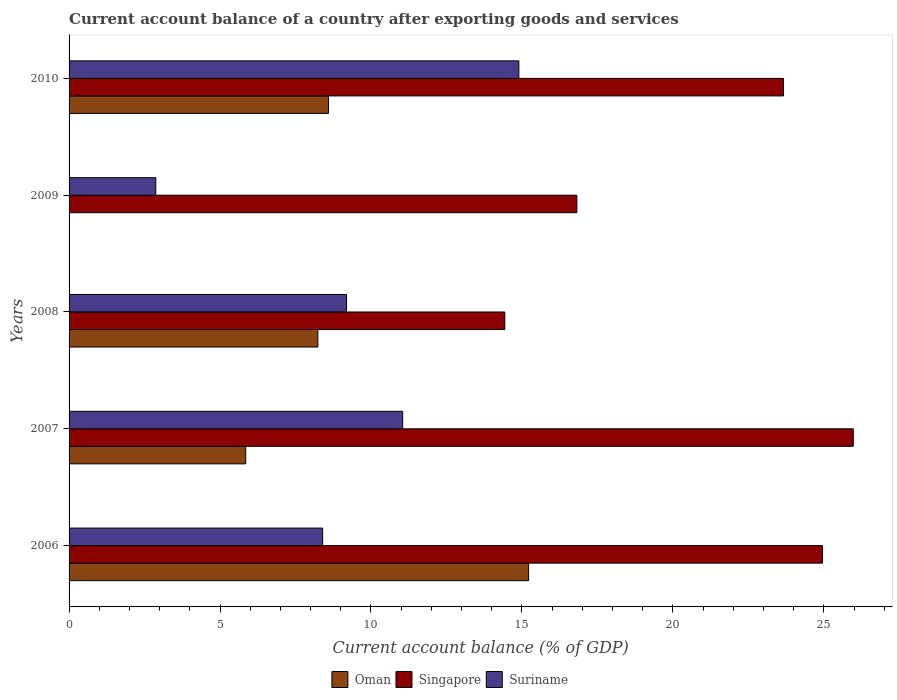How many different coloured bars are there?
Provide a succinct answer. 3. Are the number of bars per tick equal to the number of legend labels?
Your answer should be compact. No. What is the account balance in Oman in 2008?
Keep it short and to the point. 8.24. Across all years, what is the maximum account balance in Oman?
Offer a very short reply. 15.22. Across all years, what is the minimum account balance in Oman?
Provide a short and direct response. 0. In which year was the account balance in Suriname maximum?
Ensure brevity in your answer.  2010. What is the total account balance in Suriname in the graph?
Your response must be concise. 46.41. What is the difference between the account balance in Oman in 2006 and that in 2010?
Your answer should be very brief. 6.63. What is the difference between the account balance in Oman in 2006 and the account balance in Singapore in 2007?
Offer a very short reply. -10.75. What is the average account balance in Suriname per year?
Give a very brief answer. 9.28. In the year 2010, what is the difference between the account balance in Suriname and account balance in Oman?
Make the answer very short. 6.3. What is the ratio of the account balance in Suriname in 2008 to that in 2009?
Ensure brevity in your answer.  3.2. Is the account balance in Oman in 2006 less than that in 2010?
Ensure brevity in your answer.  No. What is the difference between the highest and the second highest account balance in Suriname?
Your answer should be compact. 3.85. What is the difference between the highest and the lowest account balance in Suriname?
Keep it short and to the point. 12.03. Is it the case that in every year, the sum of the account balance in Oman and account balance in Suriname is greater than the account balance in Singapore?
Provide a short and direct response. No. Are all the bars in the graph horizontal?
Provide a short and direct response. Yes. What is the difference between two consecutive major ticks on the X-axis?
Offer a terse response. 5. Are the values on the major ticks of X-axis written in scientific E-notation?
Offer a very short reply. No. Does the graph contain grids?
Keep it short and to the point. No. How many legend labels are there?
Offer a very short reply. 3. What is the title of the graph?
Ensure brevity in your answer.  Current account balance of a country after exporting goods and services. What is the label or title of the X-axis?
Offer a terse response. Current account balance (% of GDP). What is the label or title of the Y-axis?
Your answer should be very brief. Years. What is the Current account balance (% of GDP) of Oman in 2006?
Your answer should be very brief. 15.22. What is the Current account balance (% of GDP) of Singapore in 2006?
Your answer should be very brief. 24.96. What is the Current account balance (% of GDP) in Suriname in 2006?
Your answer should be very brief. 8.4. What is the Current account balance (% of GDP) of Oman in 2007?
Give a very brief answer. 5.85. What is the Current account balance (% of GDP) of Singapore in 2007?
Your answer should be compact. 25.97. What is the Current account balance (% of GDP) of Suriname in 2007?
Offer a terse response. 11.05. What is the Current account balance (% of GDP) in Oman in 2008?
Make the answer very short. 8.24. What is the Current account balance (% of GDP) of Singapore in 2008?
Keep it short and to the point. 14.43. What is the Current account balance (% of GDP) of Suriname in 2008?
Your answer should be very brief. 9.19. What is the Current account balance (% of GDP) of Singapore in 2009?
Make the answer very short. 16.82. What is the Current account balance (% of GDP) of Suriname in 2009?
Give a very brief answer. 2.87. What is the Current account balance (% of GDP) in Oman in 2010?
Keep it short and to the point. 8.59. What is the Current account balance (% of GDP) in Singapore in 2010?
Provide a succinct answer. 23.66. What is the Current account balance (% of GDP) in Suriname in 2010?
Provide a succinct answer. 14.9. Across all years, what is the maximum Current account balance (% of GDP) of Oman?
Make the answer very short. 15.22. Across all years, what is the maximum Current account balance (% of GDP) in Singapore?
Provide a succinct answer. 25.97. Across all years, what is the maximum Current account balance (% of GDP) in Suriname?
Your answer should be compact. 14.9. Across all years, what is the minimum Current account balance (% of GDP) in Singapore?
Offer a very short reply. 14.43. Across all years, what is the minimum Current account balance (% of GDP) of Suriname?
Give a very brief answer. 2.87. What is the total Current account balance (% of GDP) in Oman in the graph?
Your answer should be very brief. 37.9. What is the total Current account balance (% of GDP) in Singapore in the graph?
Offer a terse response. 105.84. What is the total Current account balance (% of GDP) in Suriname in the graph?
Offer a very short reply. 46.41. What is the difference between the Current account balance (% of GDP) of Oman in 2006 and that in 2007?
Offer a terse response. 9.37. What is the difference between the Current account balance (% of GDP) in Singapore in 2006 and that in 2007?
Provide a short and direct response. -1.02. What is the difference between the Current account balance (% of GDP) of Suriname in 2006 and that in 2007?
Your answer should be very brief. -2.65. What is the difference between the Current account balance (% of GDP) in Oman in 2006 and that in 2008?
Offer a very short reply. 6.98. What is the difference between the Current account balance (% of GDP) in Singapore in 2006 and that in 2008?
Keep it short and to the point. 10.52. What is the difference between the Current account balance (% of GDP) of Suriname in 2006 and that in 2008?
Provide a succinct answer. -0.79. What is the difference between the Current account balance (% of GDP) in Singapore in 2006 and that in 2009?
Keep it short and to the point. 8.14. What is the difference between the Current account balance (% of GDP) of Suriname in 2006 and that in 2009?
Ensure brevity in your answer.  5.53. What is the difference between the Current account balance (% of GDP) of Oman in 2006 and that in 2010?
Offer a very short reply. 6.63. What is the difference between the Current account balance (% of GDP) of Singapore in 2006 and that in 2010?
Your answer should be very brief. 1.29. What is the difference between the Current account balance (% of GDP) in Suriname in 2006 and that in 2010?
Offer a terse response. -6.5. What is the difference between the Current account balance (% of GDP) in Oman in 2007 and that in 2008?
Ensure brevity in your answer.  -2.39. What is the difference between the Current account balance (% of GDP) of Singapore in 2007 and that in 2008?
Your answer should be very brief. 11.54. What is the difference between the Current account balance (% of GDP) in Suriname in 2007 and that in 2008?
Keep it short and to the point. 1.86. What is the difference between the Current account balance (% of GDP) of Singapore in 2007 and that in 2009?
Offer a very short reply. 9.16. What is the difference between the Current account balance (% of GDP) in Suriname in 2007 and that in 2009?
Your response must be concise. 8.18. What is the difference between the Current account balance (% of GDP) of Oman in 2007 and that in 2010?
Keep it short and to the point. -2.74. What is the difference between the Current account balance (% of GDP) in Singapore in 2007 and that in 2010?
Your answer should be very brief. 2.31. What is the difference between the Current account balance (% of GDP) in Suriname in 2007 and that in 2010?
Your answer should be compact. -3.85. What is the difference between the Current account balance (% of GDP) in Singapore in 2008 and that in 2009?
Offer a very short reply. -2.39. What is the difference between the Current account balance (% of GDP) of Suriname in 2008 and that in 2009?
Provide a short and direct response. 6.32. What is the difference between the Current account balance (% of GDP) of Oman in 2008 and that in 2010?
Keep it short and to the point. -0.35. What is the difference between the Current account balance (% of GDP) of Singapore in 2008 and that in 2010?
Your answer should be very brief. -9.23. What is the difference between the Current account balance (% of GDP) in Suriname in 2008 and that in 2010?
Provide a short and direct response. -5.71. What is the difference between the Current account balance (% of GDP) of Singapore in 2009 and that in 2010?
Your response must be concise. -6.84. What is the difference between the Current account balance (% of GDP) of Suriname in 2009 and that in 2010?
Ensure brevity in your answer.  -12.03. What is the difference between the Current account balance (% of GDP) in Oman in 2006 and the Current account balance (% of GDP) in Singapore in 2007?
Offer a terse response. -10.75. What is the difference between the Current account balance (% of GDP) in Oman in 2006 and the Current account balance (% of GDP) in Suriname in 2007?
Keep it short and to the point. 4.17. What is the difference between the Current account balance (% of GDP) of Singapore in 2006 and the Current account balance (% of GDP) of Suriname in 2007?
Offer a terse response. 13.91. What is the difference between the Current account balance (% of GDP) in Oman in 2006 and the Current account balance (% of GDP) in Singapore in 2008?
Give a very brief answer. 0.79. What is the difference between the Current account balance (% of GDP) in Oman in 2006 and the Current account balance (% of GDP) in Suriname in 2008?
Provide a succinct answer. 6.03. What is the difference between the Current account balance (% of GDP) in Singapore in 2006 and the Current account balance (% of GDP) in Suriname in 2008?
Your response must be concise. 15.77. What is the difference between the Current account balance (% of GDP) of Oman in 2006 and the Current account balance (% of GDP) of Singapore in 2009?
Provide a succinct answer. -1.6. What is the difference between the Current account balance (% of GDP) of Oman in 2006 and the Current account balance (% of GDP) of Suriname in 2009?
Offer a terse response. 12.35. What is the difference between the Current account balance (% of GDP) in Singapore in 2006 and the Current account balance (% of GDP) in Suriname in 2009?
Make the answer very short. 22.08. What is the difference between the Current account balance (% of GDP) in Oman in 2006 and the Current account balance (% of GDP) in Singapore in 2010?
Offer a terse response. -8.44. What is the difference between the Current account balance (% of GDP) in Oman in 2006 and the Current account balance (% of GDP) in Suriname in 2010?
Your response must be concise. 0.32. What is the difference between the Current account balance (% of GDP) in Singapore in 2006 and the Current account balance (% of GDP) in Suriname in 2010?
Your response must be concise. 10.06. What is the difference between the Current account balance (% of GDP) of Oman in 2007 and the Current account balance (% of GDP) of Singapore in 2008?
Provide a short and direct response. -8.58. What is the difference between the Current account balance (% of GDP) in Oman in 2007 and the Current account balance (% of GDP) in Suriname in 2008?
Give a very brief answer. -3.34. What is the difference between the Current account balance (% of GDP) of Singapore in 2007 and the Current account balance (% of GDP) of Suriname in 2008?
Offer a very short reply. 16.78. What is the difference between the Current account balance (% of GDP) of Oman in 2007 and the Current account balance (% of GDP) of Singapore in 2009?
Ensure brevity in your answer.  -10.97. What is the difference between the Current account balance (% of GDP) in Oman in 2007 and the Current account balance (% of GDP) in Suriname in 2009?
Ensure brevity in your answer.  2.98. What is the difference between the Current account balance (% of GDP) in Singapore in 2007 and the Current account balance (% of GDP) in Suriname in 2009?
Your response must be concise. 23.1. What is the difference between the Current account balance (% of GDP) of Oman in 2007 and the Current account balance (% of GDP) of Singapore in 2010?
Offer a terse response. -17.81. What is the difference between the Current account balance (% of GDP) in Oman in 2007 and the Current account balance (% of GDP) in Suriname in 2010?
Your answer should be very brief. -9.05. What is the difference between the Current account balance (% of GDP) of Singapore in 2007 and the Current account balance (% of GDP) of Suriname in 2010?
Your answer should be very brief. 11.08. What is the difference between the Current account balance (% of GDP) of Oman in 2008 and the Current account balance (% of GDP) of Singapore in 2009?
Your answer should be compact. -8.58. What is the difference between the Current account balance (% of GDP) in Oman in 2008 and the Current account balance (% of GDP) in Suriname in 2009?
Your answer should be very brief. 5.37. What is the difference between the Current account balance (% of GDP) in Singapore in 2008 and the Current account balance (% of GDP) in Suriname in 2009?
Give a very brief answer. 11.56. What is the difference between the Current account balance (% of GDP) in Oman in 2008 and the Current account balance (% of GDP) in Singapore in 2010?
Your answer should be compact. -15.42. What is the difference between the Current account balance (% of GDP) of Oman in 2008 and the Current account balance (% of GDP) of Suriname in 2010?
Provide a short and direct response. -6.66. What is the difference between the Current account balance (% of GDP) of Singapore in 2008 and the Current account balance (% of GDP) of Suriname in 2010?
Your answer should be compact. -0.47. What is the difference between the Current account balance (% of GDP) of Singapore in 2009 and the Current account balance (% of GDP) of Suriname in 2010?
Make the answer very short. 1.92. What is the average Current account balance (% of GDP) of Oman per year?
Give a very brief answer. 7.58. What is the average Current account balance (% of GDP) of Singapore per year?
Offer a very short reply. 21.17. What is the average Current account balance (% of GDP) of Suriname per year?
Ensure brevity in your answer.  9.28. In the year 2006, what is the difference between the Current account balance (% of GDP) of Oman and Current account balance (% of GDP) of Singapore?
Give a very brief answer. -9.74. In the year 2006, what is the difference between the Current account balance (% of GDP) in Oman and Current account balance (% of GDP) in Suriname?
Ensure brevity in your answer.  6.82. In the year 2006, what is the difference between the Current account balance (% of GDP) in Singapore and Current account balance (% of GDP) in Suriname?
Provide a succinct answer. 16.56. In the year 2007, what is the difference between the Current account balance (% of GDP) of Oman and Current account balance (% of GDP) of Singapore?
Offer a very short reply. -20.12. In the year 2007, what is the difference between the Current account balance (% of GDP) in Oman and Current account balance (% of GDP) in Suriname?
Offer a terse response. -5.2. In the year 2007, what is the difference between the Current account balance (% of GDP) of Singapore and Current account balance (% of GDP) of Suriname?
Provide a short and direct response. 14.92. In the year 2008, what is the difference between the Current account balance (% of GDP) of Oman and Current account balance (% of GDP) of Singapore?
Provide a succinct answer. -6.19. In the year 2008, what is the difference between the Current account balance (% of GDP) of Oman and Current account balance (% of GDP) of Suriname?
Your answer should be compact. -0.95. In the year 2008, what is the difference between the Current account balance (% of GDP) of Singapore and Current account balance (% of GDP) of Suriname?
Your answer should be very brief. 5.24. In the year 2009, what is the difference between the Current account balance (% of GDP) of Singapore and Current account balance (% of GDP) of Suriname?
Keep it short and to the point. 13.95. In the year 2010, what is the difference between the Current account balance (% of GDP) of Oman and Current account balance (% of GDP) of Singapore?
Ensure brevity in your answer.  -15.07. In the year 2010, what is the difference between the Current account balance (% of GDP) in Oman and Current account balance (% of GDP) in Suriname?
Make the answer very short. -6.3. In the year 2010, what is the difference between the Current account balance (% of GDP) in Singapore and Current account balance (% of GDP) in Suriname?
Offer a very short reply. 8.76. What is the ratio of the Current account balance (% of GDP) of Oman in 2006 to that in 2007?
Your answer should be very brief. 2.6. What is the ratio of the Current account balance (% of GDP) in Singapore in 2006 to that in 2007?
Provide a succinct answer. 0.96. What is the ratio of the Current account balance (% of GDP) in Suriname in 2006 to that in 2007?
Your response must be concise. 0.76. What is the ratio of the Current account balance (% of GDP) of Oman in 2006 to that in 2008?
Keep it short and to the point. 1.85. What is the ratio of the Current account balance (% of GDP) of Singapore in 2006 to that in 2008?
Your answer should be very brief. 1.73. What is the ratio of the Current account balance (% of GDP) of Suriname in 2006 to that in 2008?
Provide a short and direct response. 0.91. What is the ratio of the Current account balance (% of GDP) in Singapore in 2006 to that in 2009?
Provide a short and direct response. 1.48. What is the ratio of the Current account balance (% of GDP) of Suriname in 2006 to that in 2009?
Provide a short and direct response. 2.92. What is the ratio of the Current account balance (% of GDP) of Oman in 2006 to that in 2010?
Provide a short and direct response. 1.77. What is the ratio of the Current account balance (% of GDP) in Singapore in 2006 to that in 2010?
Your response must be concise. 1.05. What is the ratio of the Current account balance (% of GDP) in Suriname in 2006 to that in 2010?
Give a very brief answer. 0.56. What is the ratio of the Current account balance (% of GDP) in Oman in 2007 to that in 2008?
Your answer should be very brief. 0.71. What is the ratio of the Current account balance (% of GDP) in Singapore in 2007 to that in 2008?
Offer a very short reply. 1.8. What is the ratio of the Current account balance (% of GDP) in Suriname in 2007 to that in 2008?
Ensure brevity in your answer.  1.2. What is the ratio of the Current account balance (% of GDP) in Singapore in 2007 to that in 2009?
Offer a very short reply. 1.54. What is the ratio of the Current account balance (% of GDP) in Suriname in 2007 to that in 2009?
Offer a terse response. 3.85. What is the ratio of the Current account balance (% of GDP) of Oman in 2007 to that in 2010?
Ensure brevity in your answer.  0.68. What is the ratio of the Current account balance (% of GDP) of Singapore in 2007 to that in 2010?
Give a very brief answer. 1.1. What is the ratio of the Current account balance (% of GDP) in Suriname in 2007 to that in 2010?
Provide a succinct answer. 0.74. What is the ratio of the Current account balance (% of GDP) in Singapore in 2008 to that in 2009?
Offer a terse response. 0.86. What is the ratio of the Current account balance (% of GDP) of Suriname in 2008 to that in 2009?
Offer a terse response. 3.2. What is the ratio of the Current account balance (% of GDP) in Oman in 2008 to that in 2010?
Your answer should be compact. 0.96. What is the ratio of the Current account balance (% of GDP) in Singapore in 2008 to that in 2010?
Provide a short and direct response. 0.61. What is the ratio of the Current account balance (% of GDP) of Suriname in 2008 to that in 2010?
Your answer should be compact. 0.62. What is the ratio of the Current account balance (% of GDP) in Singapore in 2009 to that in 2010?
Your response must be concise. 0.71. What is the ratio of the Current account balance (% of GDP) in Suriname in 2009 to that in 2010?
Ensure brevity in your answer.  0.19. What is the difference between the highest and the second highest Current account balance (% of GDP) of Oman?
Make the answer very short. 6.63. What is the difference between the highest and the second highest Current account balance (% of GDP) in Singapore?
Offer a very short reply. 1.02. What is the difference between the highest and the second highest Current account balance (% of GDP) of Suriname?
Provide a succinct answer. 3.85. What is the difference between the highest and the lowest Current account balance (% of GDP) of Oman?
Offer a terse response. 15.22. What is the difference between the highest and the lowest Current account balance (% of GDP) in Singapore?
Offer a terse response. 11.54. What is the difference between the highest and the lowest Current account balance (% of GDP) in Suriname?
Ensure brevity in your answer.  12.03. 